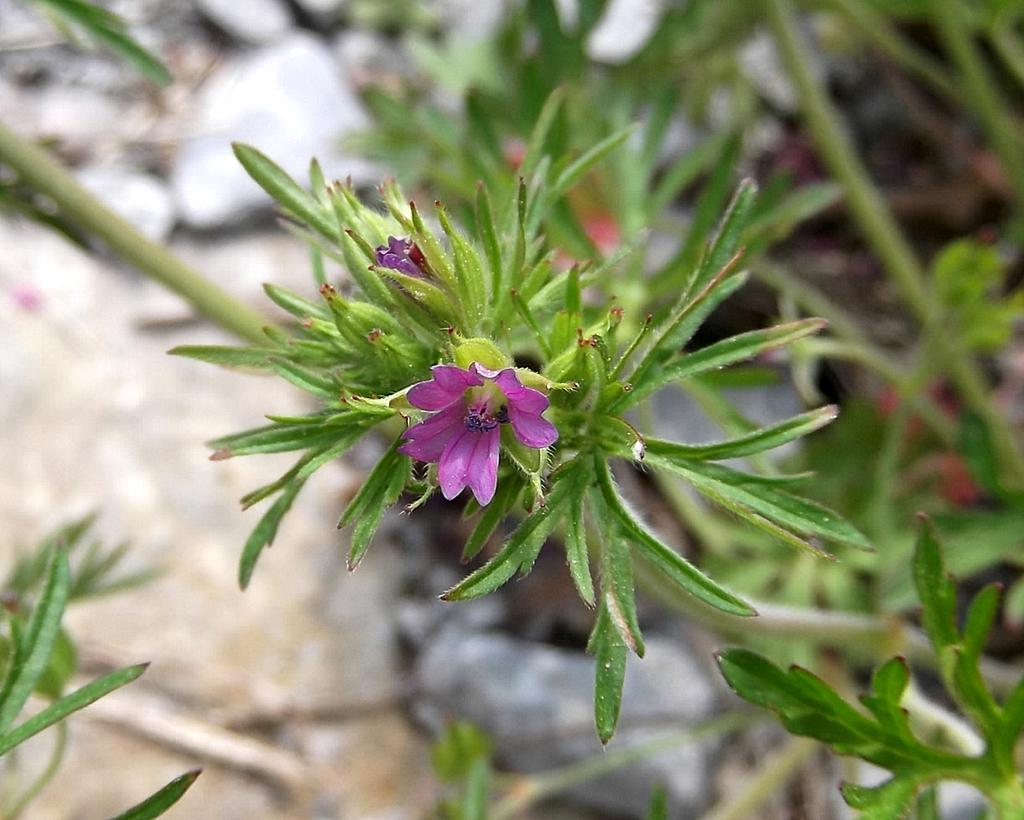What type of plant is visible in the image? There are flowers on a plant in the image. What can be found on the ground in the image? There are stones on the ground in the image, although they are described as blurry. How many eyes does the snail have in the image? There is no snail present in the image, so it is not possible to determine the number of eyes it might have. What is the cause of the fire in the image? There is no fire present in the image, so it is not possible to determine the cause of a fire that does not exist. 